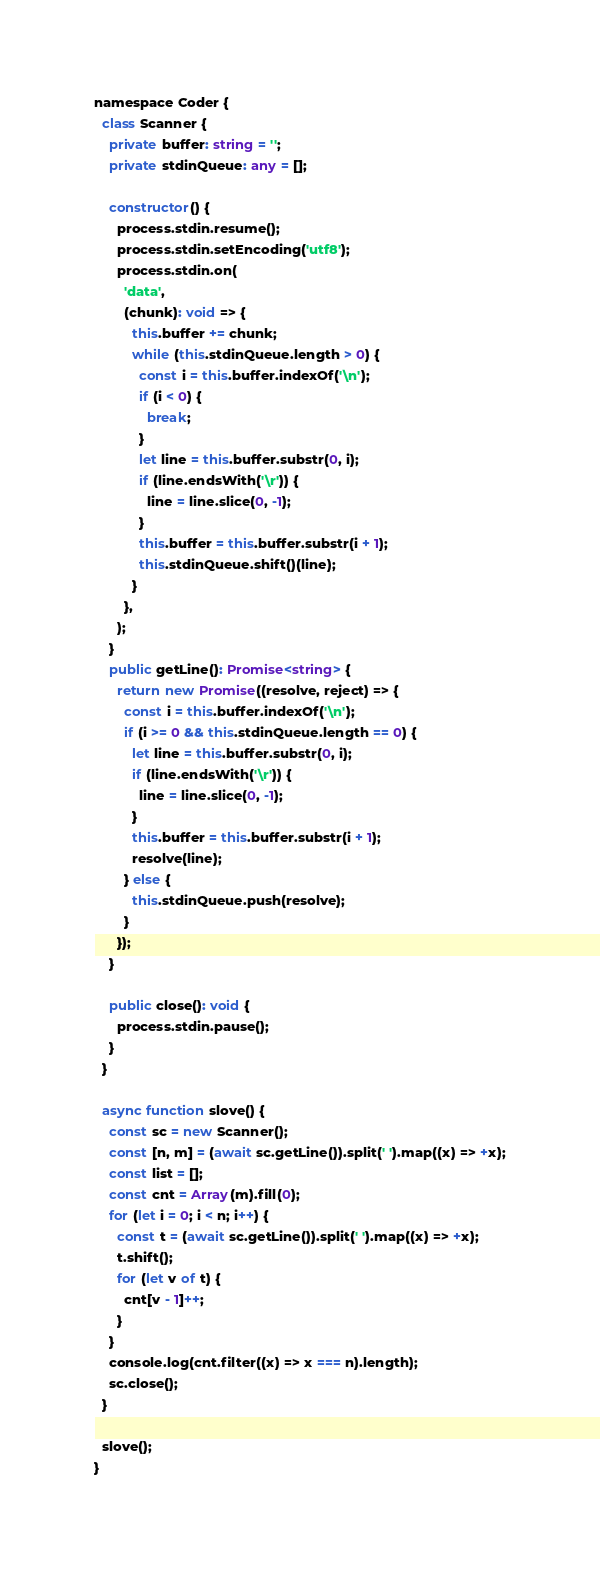<code> <loc_0><loc_0><loc_500><loc_500><_TypeScript_>namespace Coder {
  class Scanner {
    private buffer: string = '';
    private stdinQueue: any = [];

    constructor() {
      process.stdin.resume();
      process.stdin.setEncoding('utf8');
      process.stdin.on(
        'data',
        (chunk): void => {
          this.buffer += chunk;
          while (this.stdinQueue.length > 0) {
            const i = this.buffer.indexOf('\n');
            if (i < 0) {
              break;
            }
            let line = this.buffer.substr(0, i);
            if (line.endsWith('\r')) {
              line = line.slice(0, -1);
            }
            this.buffer = this.buffer.substr(i + 1);
            this.stdinQueue.shift()(line);
          }
        },
      );
    }
    public getLine(): Promise<string> {
      return new Promise((resolve, reject) => {
        const i = this.buffer.indexOf('\n');
        if (i >= 0 && this.stdinQueue.length == 0) {
          let line = this.buffer.substr(0, i);
          if (line.endsWith('\r')) {
            line = line.slice(0, -1);
          }
          this.buffer = this.buffer.substr(i + 1);
          resolve(line);
        } else {
          this.stdinQueue.push(resolve);
        }
      });
    }

    public close(): void {
      process.stdin.pause();
    }
  }

  async function slove() {
    const sc = new Scanner();
    const [n, m] = (await sc.getLine()).split(' ').map((x) => +x);
    const list = [];
    const cnt = Array(m).fill(0);
    for (let i = 0; i < n; i++) {
      const t = (await sc.getLine()).split(' ').map((x) => +x);
      t.shift();
      for (let v of t) {
        cnt[v - 1]++;
      }
    }
    console.log(cnt.filter((x) => x === n).length);
    sc.close();
  }

  slove();
}
</code> 